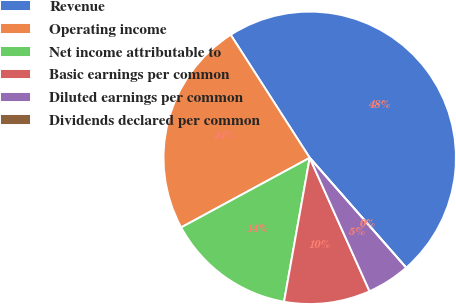Convert chart to OTSL. <chart><loc_0><loc_0><loc_500><loc_500><pie_chart><fcel>Revenue<fcel>Operating income<fcel>Net income attributable to<fcel>Basic earnings per common<fcel>Diluted earnings per common<fcel>Dividends declared per common<nl><fcel>47.62%<fcel>23.81%<fcel>14.29%<fcel>9.52%<fcel>4.76%<fcel>0.0%<nl></chart> 